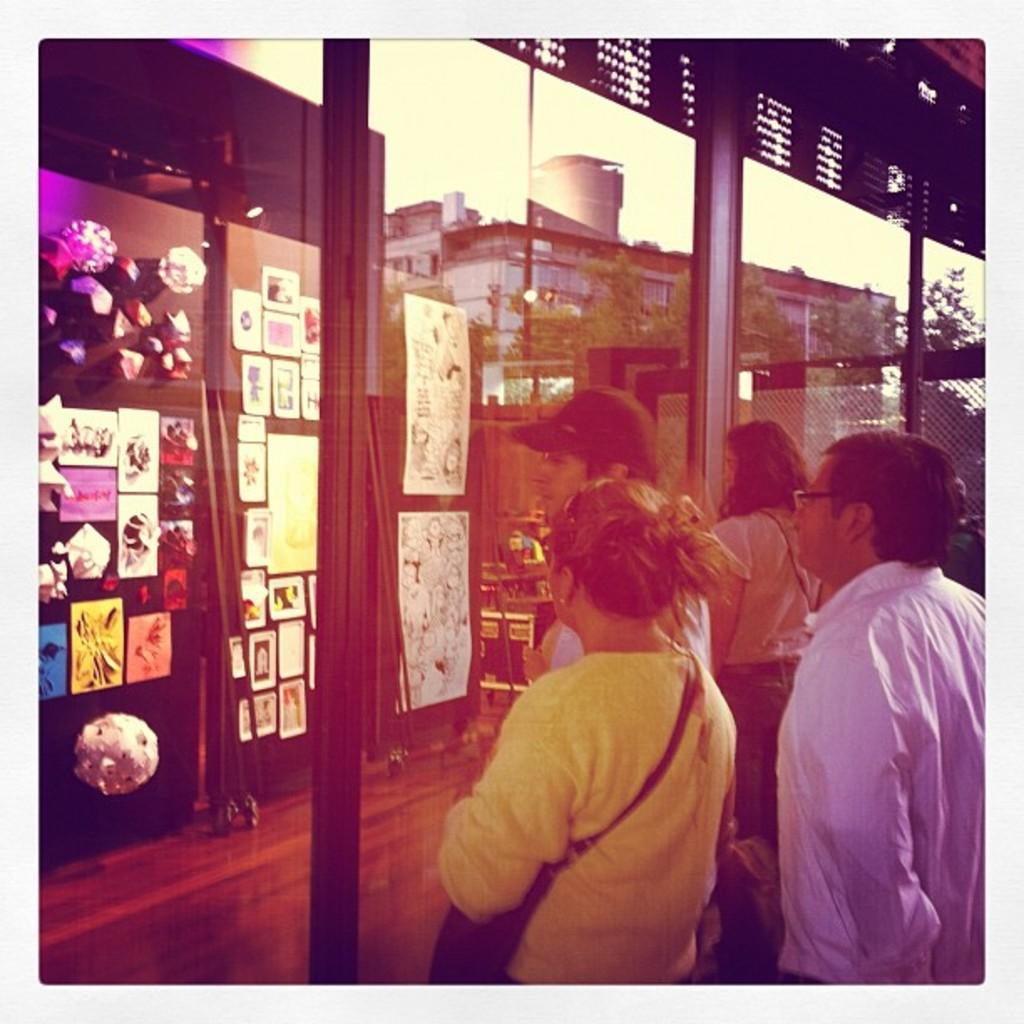Please provide a concise description of this image. In this image I can see group of people standing, in front the person is wearing yellow color shirt and the person at right wearing white color shirt, in front I can see a glass wall. I can also see few papers attached to some object. Background I can see a building and the sky is in white color. 